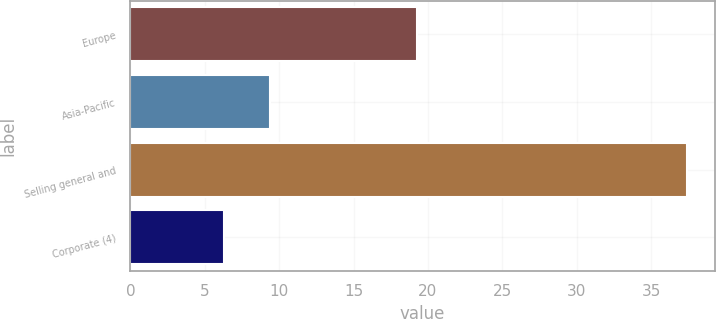<chart> <loc_0><loc_0><loc_500><loc_500><bar_chart><fcel>Europe<fcel>Asia-Pacific<fcel>Selling general and<fcel>Corporate (4)<nl><fcel>19.3<fcel>9.41<fcel>37.4<fcel>6.3<nl></chart> 